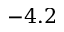<formula> <loc_0><loc_0><loc_500><loc_500>- 4 . 2</formula> 